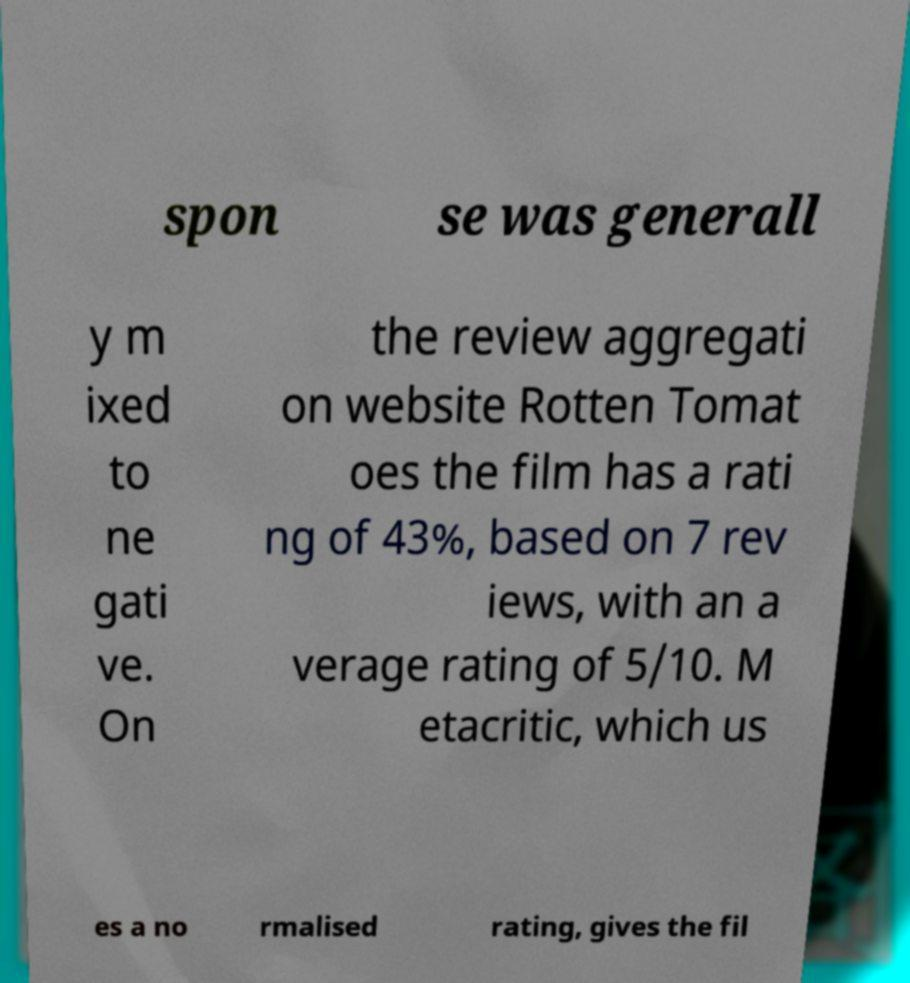Can you accurately transcribe the text from the provided image for me? spon se was generall y m ixed to ne gati ve. On the review aggregati on website Rotten Tomat oes the film has a rati ng of 43%, based on 7 rev iews, with an a verage rating of 5/10. M etacritic, which us es a no rmalised rating, gives the fil 